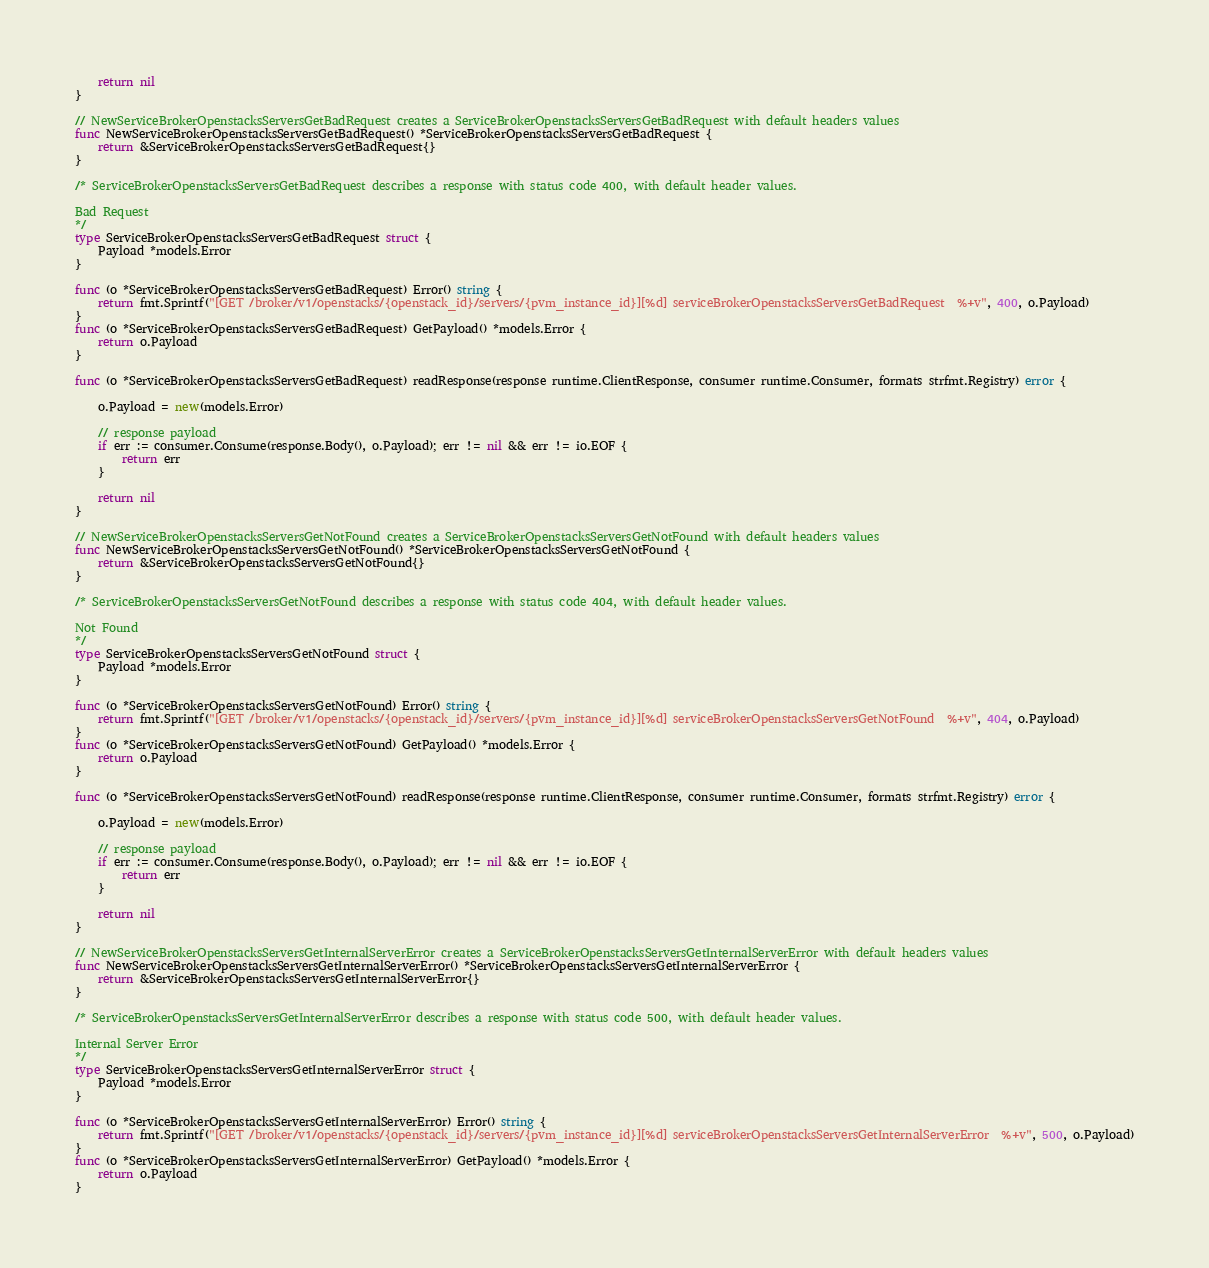<code> <loc_0><loc_0><loc_500><loc_500><_Go_>
	return nil
}

// NewServiceBrokerOpenstacksServersGetBadRequest creates a ServiceBrokerOpenstacksServersGetBadRequest with default headers values
func NewServiceBrokerOpenstacksServersGetBadRequest() *ServiceBrokerOpenstacksServersGetBadRequest {
	return &ServiceBrokerOpenstacksServersGetBadRequest{}
}

/* ServiceBrokerOpenstacksServersGetBadRequest describes a response with status code 400, with default header values.

Bad Request
*/
type ServiceBrokerOpenstacksServersGetBadRequest struct {
	Payload *models.Error
}

func (o *ServiceBrokerOpenstacksServersGetBadRequest) Error() string {
	return fmt.Sprintf("[GET /broker/v1/openstacks/{openstack_id}/servers/{pvm_instance_id}][%d] serviceBrokerOpenstacksServersGetBadRequest  %+v", 400, o.Payload)
}
func (o *ServiceBrokerOpenstacksServersGetBadRequest) GetPayload() *models.Error {
	return o.Payload
}

func (o *ServiceBrokerOpenstacksServersGetBadRequest) readResponse(response runtime.ClientResponse, consumer runtime.Consumer, formats strfmt.Registry) error {

	o.Payload = new(models.Error)

	// response payload
	if err := consumer.Consume(response.Body(), o.Payload); err != nil && err != io.EOF {
		return err
	}

	return nil
}

// NewServiceBrokerOpenstacksServersGetNotFound creates a ServiceBrokerOpenstacksServersGetNotFound with default headers values
func NewServiceBrokerOpenstacksServersGetNotFound() *ServiceBrokerOpenstacksServersGetNotFound {
	return &ServiceBrokerOpenstacksServersGetNotFound{}
}

/* ServiceBrokerOpenstacksServersGetNotFound describes a response with status code 404, with default header values.

Not Found
*/
type ServiceBrokerOpenstacksServersGetNotFound struct {
	Payload *models.Error
}

func (o *ServiceBrokerOpenstacksServersGetNotFound) Error() string {
	return fmt.Sprintf("[GET /broker/v1/openstacks/{openstack_id}/servers/{pvm_instance_id}][%d] serviceBrokerOpenstacksServersGetNotFound  %+v", 404, o.Payload)
}
func (o *ServiceBrokerOpenstacksServersGetNotFound) GetPayload() *models.Error {
	return o.Payload
}

func (o *ServiceBrokerOpenstacksServersGetNotFound) readResponse(response runtime.ClientResponse, consumer runtime.Consumer, formats strfmt.Registry) error {

	o.Payload = new(models.Error)

	// response payload
	if err := consumer.Consume(response.Body(), o.Payload); err != nil && err != io.EOF {
		return err
	}

	return nil
}

// NewServiceBrokerOpenstacksServersGetInternalServerError creates a ServiceBrokerOpenstacksServersGetInternalServerError with default headers values
func NewServiceBrokerOpenstacksServersGetInternalServerError() *ServiceBrokerOpenstacksServersGetInternalServerError {
	return &ServiceBrokerOpenstacksServersGetInternalServerError{}
}

/* ServiceBrokerOpenstacksServersGetInternalServerError describes a response with status code 500, with default header values.

Internal Server Error
*/
type ServiceBrokerOpenstacksServersGetInternalServerError struct {
	Payload *models.Error
}

func (o *ServiceBrokerOpenstacksServersGetInternalServerError) Error() string {
	return fmt.Sprintf("[GET /broker/v1/openstacks/{openstack_id}/servers/{pvm_instance_id}][%d] serviceBrokerOpenstacksServersGetInternalServerError  %+v", 500, o.Payload)
}
func (o *ServiceBrokerOpenstacksServersGetInternalServerError) GetPayload() *models.Error {
	return o.Payload
}
</code> 